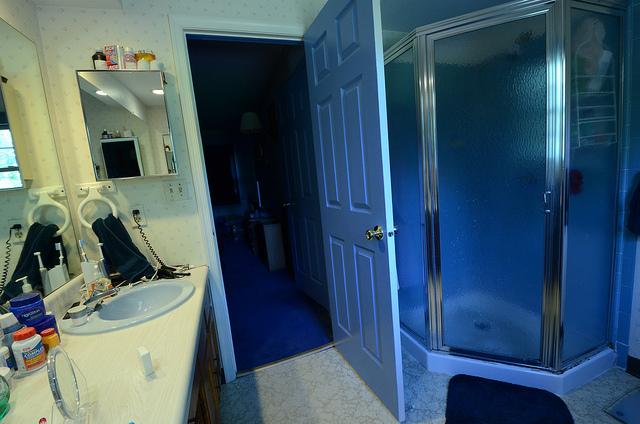What room is this?
Write a very short answer. Bathroom. Name the type of door open in the picture?
Write a very short answer. Wood. Is there a sink in the picture?
Give a very brief answer. Yes. What color is the carpet leading to the bathroom?
Write a very short answer. Blue. 